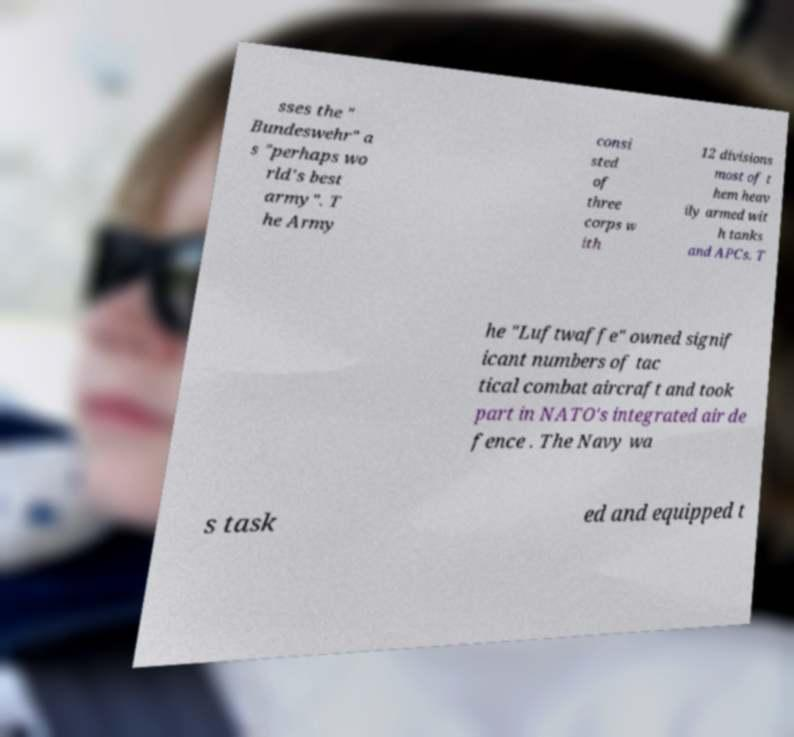Please read and relay the text visible in this image. What does it say? sses the " Bundeswehr" a s "perhaps wo rld's best army". T he Army consi sted of three corps w ith 12 divisions most of t hem heav ily armed wit h tanks and APCs. T he "Luftwaffe" owned signif icant numbers of tac tical combat aircraft and took part in NATO's integrated air de fence . The Navy wa s task ed and equipped t 